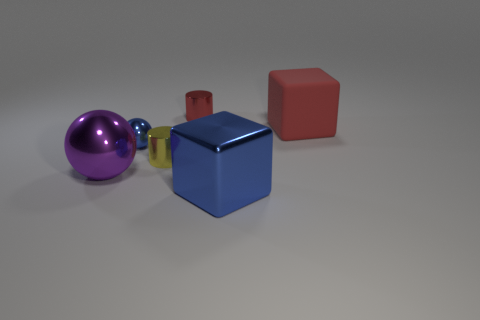What number of metallic cylinders have the same color as the matte object?
Your answer should be very brief. 1. There is a tiny object that is in front of the small blue metal thing; what material is it?
Provide a succinct answer. Metal. The yellow thing that is made of the same material as the tiny red object is what size?
Give a very brief answer. Small. Is the size of the blue metal object that is on the right side of the red shiny cylinder the same as the block behind the big blue metal thing?
Your answer should be very brief. Yes. What is the material of the purple ball that is the same size as the red rubber cube?
Provide a short and direct response. Metal. There is a thing that is both to the left of the metal block and behind the blue metal ball; what is its material?
Your answer should be very brief. Metal. Is there a red cube?
Ensure brevity in your answer.  Yes. Do the small ball and the big object behind the large purple metal object have the same color?
Offer a very short reply. No. There is a cube that is the same color as the small shiny sphere; what is its material?
Your response must be concise. Metal. Are there any other things that are the same shape as the large purple shiny object?
Provide a short and direct response. Yes. 